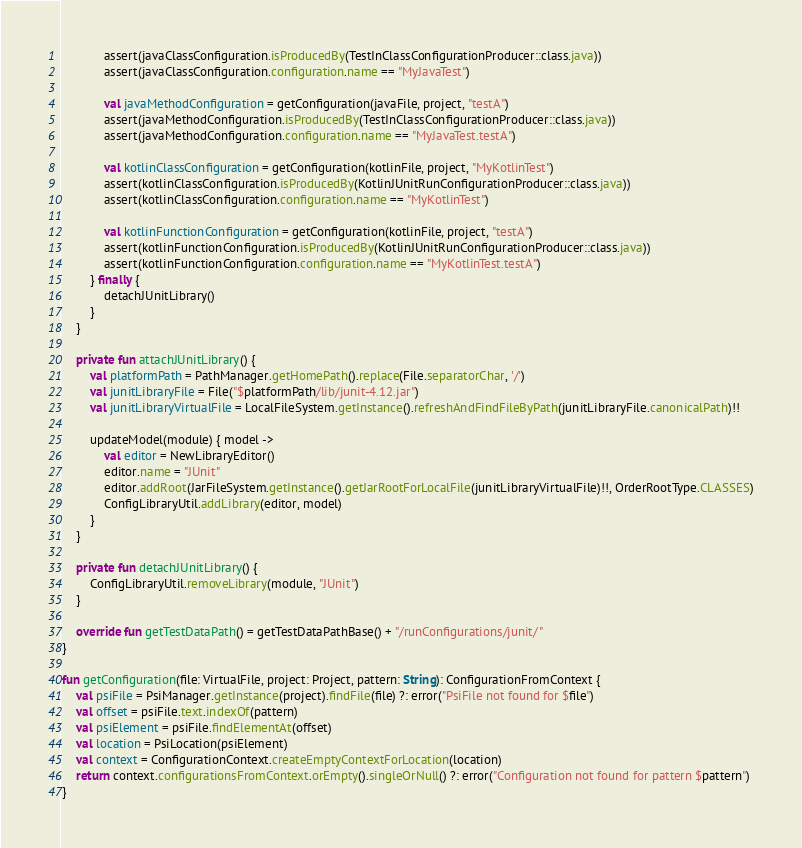<code> <loc_0><loc_0><loc_500><loc_500><_Kotlin_>            assert(javaClassConfiguration.isProducedBy(TestInClassConfigurationProducer::class.java))
            assert(javaClassConfiguration.configuration.name == "MyJavaTest")

            val javaMethodConfiguration = getConfiguration(javaFile, project, "testA")
            assert(javaMethodConfiguration.isProducedBy(TestInClassConfigurationProducer::class.java))
            assert(javaMethodConfiguration.configuration.name == "MyJavaTest.testA")

            val kotlinClassConfiguration = getConfiguration(kotlinFile, project, "MyKotlinTest")
            assert(kotlinClassConfiguration.isProducedBy(KotlinJUnitRunConfigurationProducer::class.java))
            assert(kotlinClassConfiguration.configuration.name == "MyKotlinTest")

            val kotlinFunctionConfiguration = getConfiguration(kotlinFile, project, "testA")
            assert(kotlinFunctionConfiguration.isProducedBy(KotlinJUnitRunConfigurationProducer::class.java))
            assert(kotlinFunctionConfiguration.configuration.name == "MyKotlinTest.testA")
        } finally {
            detachJUnitLibrary()
        }
    }

    private fun attachJUnitLibrary() {
        val platformPath = PathManager.getHomePath().replace(File.separatorChar, '/')
        val junitLibraryFile = File("$platformPath/lib/junit-4.12.jar")
        val junitLibraryVirtualFile = LocalFileSystem.getInstance().refreshAndFindFileByPath(junitLibraryFile.canonicalPath)!!

        updateModel(module) { model ->
            val editor = NewLibraryEditor()
            editor.name = "JUnit"
            editor.addRoot(JarFileSystem.getInstance().getJarRootForLocalFile(junitLibraryVirtualFile)!!, OrderRootType.CLASSES)
            ConfigLibraryUtil.addLibrary(editor, model)
        }
    }

    private fun detachJUnitLibrary() {
        ConfigLibraryUtil.removeLibrary(module, "JUnit")
    }

    override fun getTestDataPath() = getTestDataPathBase() + "/runConfigurations/junit/"
}

fun getConfiguration(file: VirtualFile, project: Project, pattern: String): ConfigurationFromContext {
    val psiFile = PsiManager.getInstance(project).findFile(file) ?: error("PsiFile not found for $file")
    val offset = psiFile.text.indexOf(pattern)
    val psiElement = psiFile.findElementAt(offset)
    val location = PsiLocation(psiElement)
    val context = ConfigurationContext.createEmptyContextForLocation(location)
    return context.configurationsFromContext.orEmpty().singleOrNull() ?: error("Configuration not found for pattern $pattern")
}</code> 